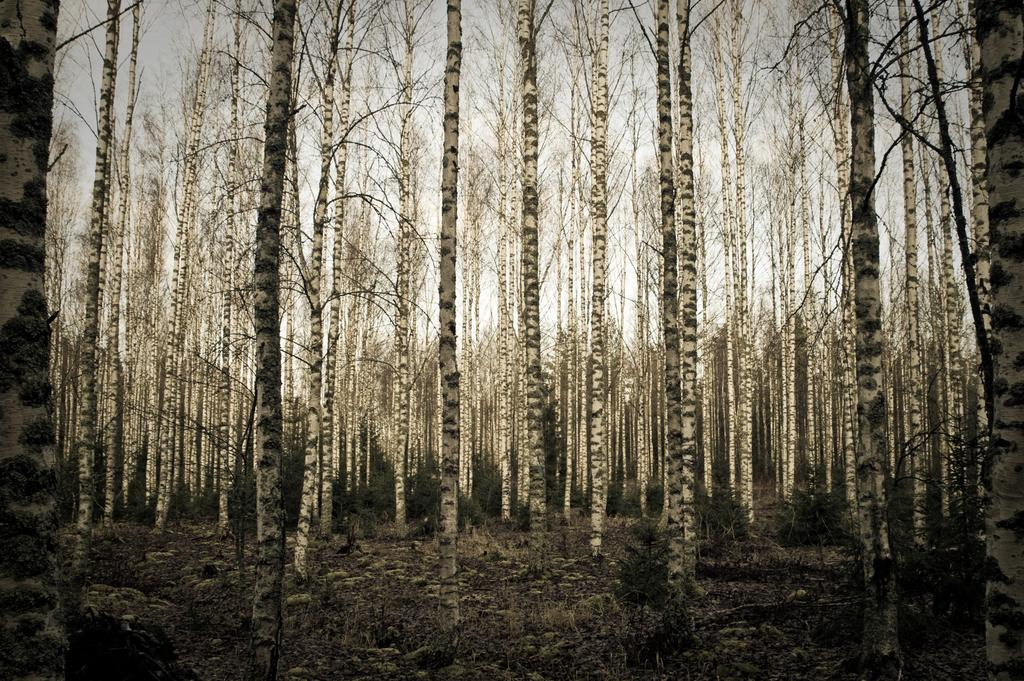What type of vegetation can be seen in the image? There are plants and trees in the image. What part of the natural environment is visible in the image? The sky is visible in the background of the image. What is the copper object being pulled by the plants in the image? There is no copper object or any object being pulled in the image; it features plants, trees, and the sky. 